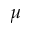Convert formula to latex. <formula><loc_0><loc_0><loc_500><loc_500>\mu</formula> 